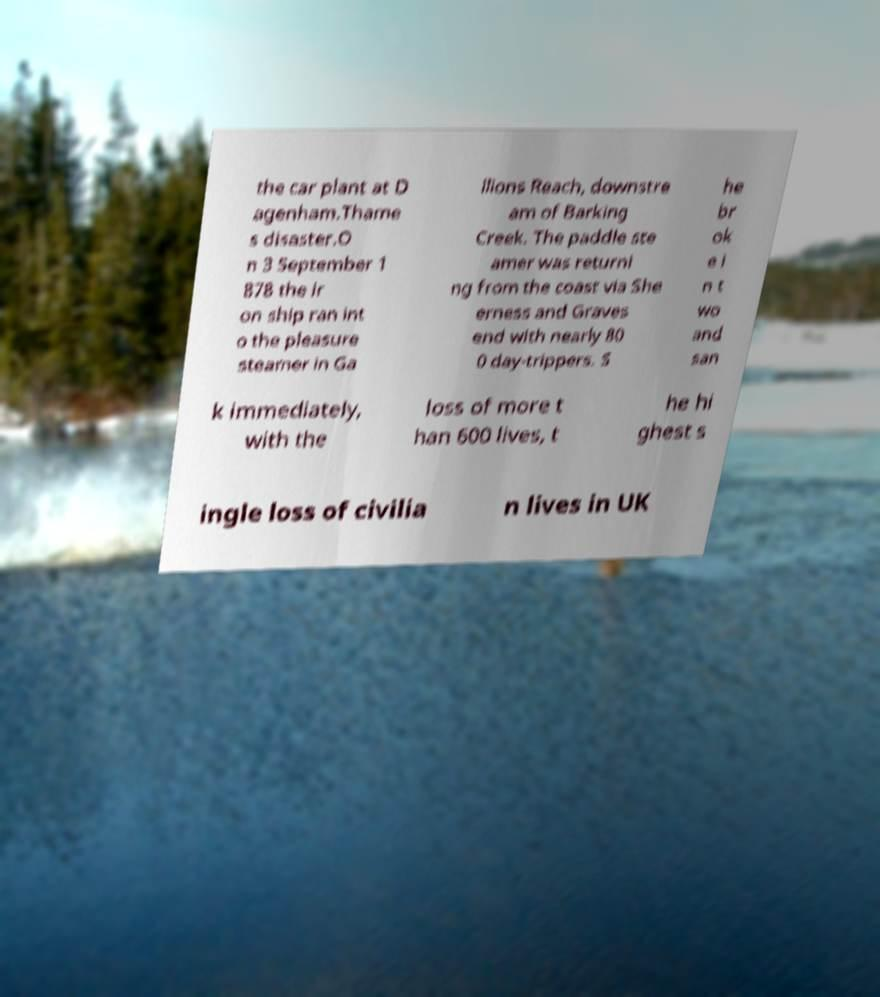For documentation purposes, I need the text within this image transcribed. Could you provide that? the car plant at D agenham.Thame s disaster.O n 3 September 1 878 the ir on ship ran int o the pleasure steamer in Ga llions Reach, downstre am of Barking Creek. The paddle ste amer was returni ng from the coast via She erness and Graves end with nearly 80 0 day-trippers. S he br ok e i n t wo and san k immediately, with the loss of more t han 600 lives, t he hi ghest s ingle loss of civilia n lives in UK 